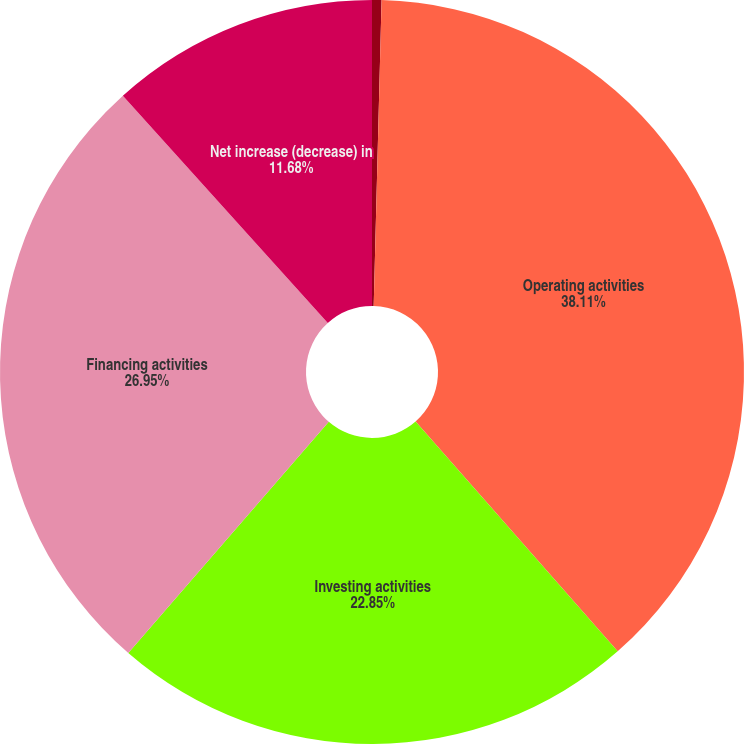Convert chart. <chart><loc_0><loc_0><loc_500><loc_500><pie_chart><fcel>Cash and cash equivalents at<fcel>Operating activities<fcel>Investing activities<fcel>Financing activities<fcel>Net increase (decrease) in<nl><fcel>0.41%<fcel>38.11%<fcel>22.85%<fcel>26.95%<fcel>11.68%<nl></chart> 